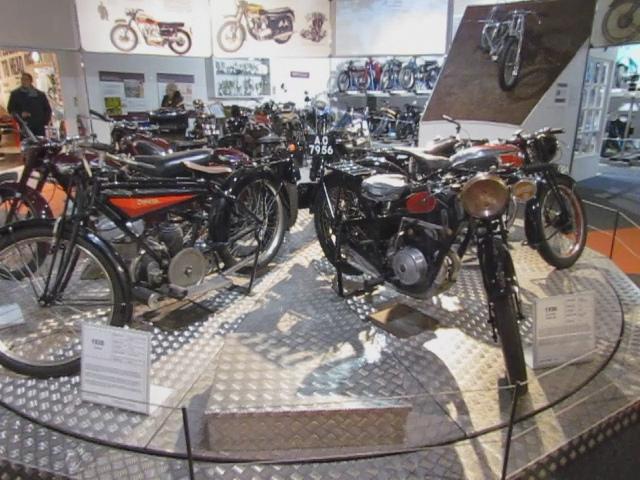What are the bikes on?
Quick response, please. Platform. Are these bikes antique?
Concise answer only. Yes. Where are these bikes displayed?
Be succinct. Store. 